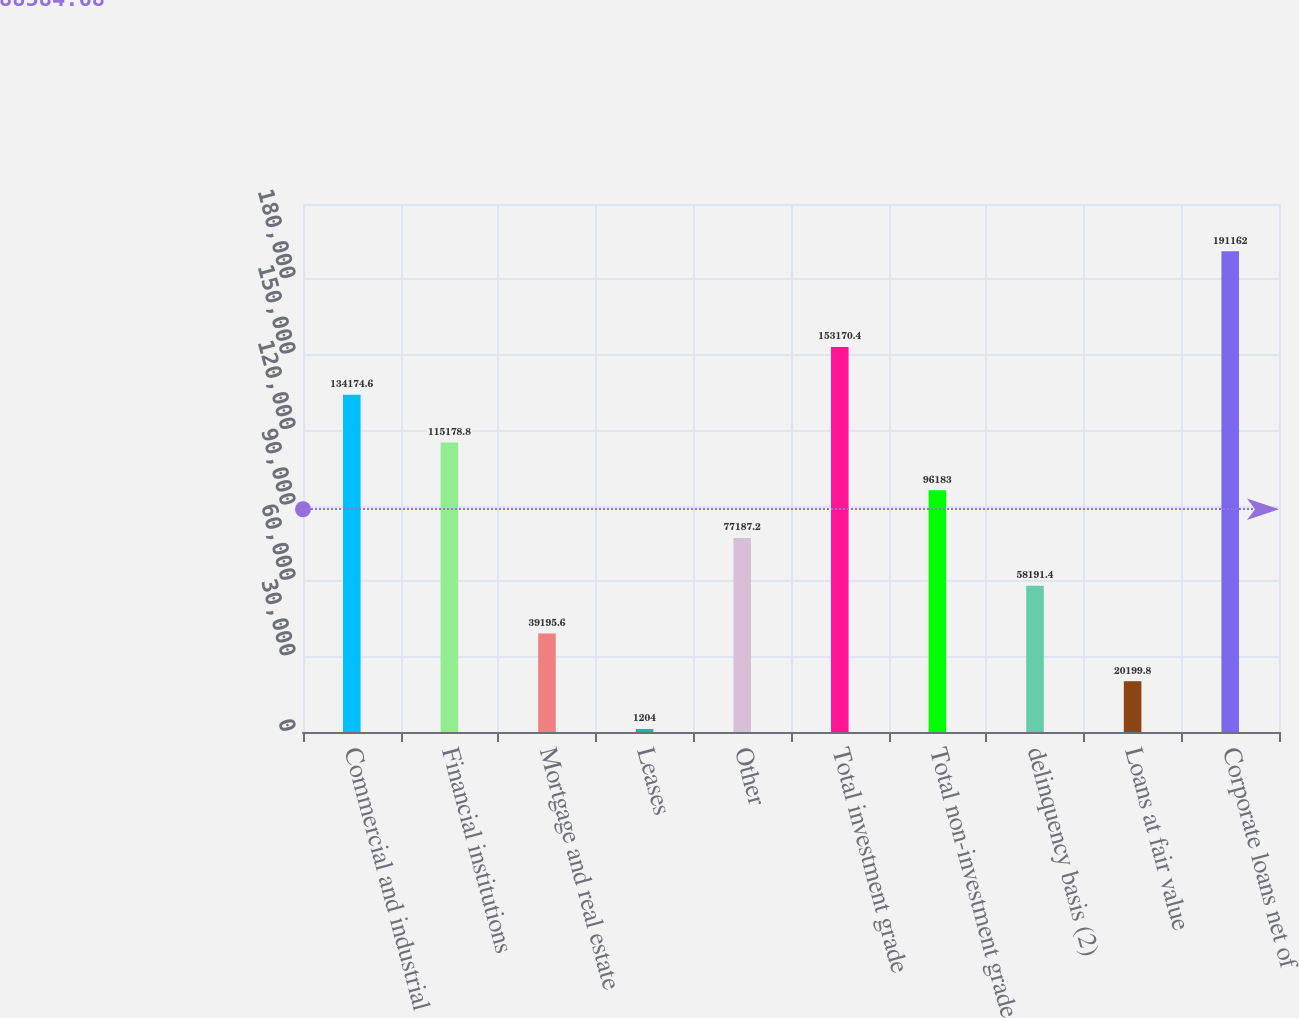Convert chart to OTSL. <chart><loc_0><loc_0><loc_500><loc_500><bar_chart><fcel>Commercial and industrial<fcel>Financial institutions<fcel>Mortgage and real estate<fcel>Leases<fcel>Other<fcel>Total investment grade<fcel>Total non-investment grade<fcel>delinquency basis (2)<fcel>Loans at fair value<fcel>Corporate loans net of<nl><fcel>134175<fcel>115179<fcel>39195.6<fcel>1204<fcel>77187.2<fcel>153170<fcel>96183<fcel>58191.4<fcel>20199.8<fcel>191162<nl></chart> 